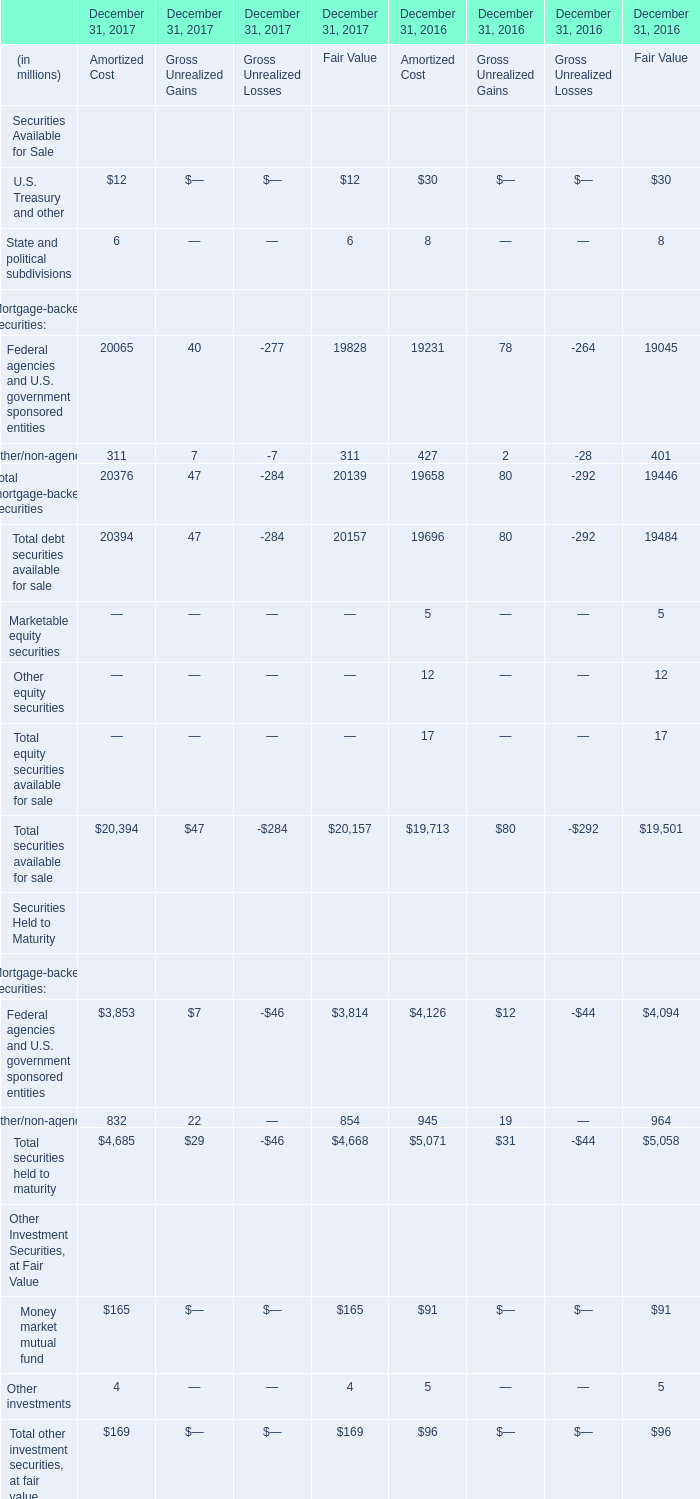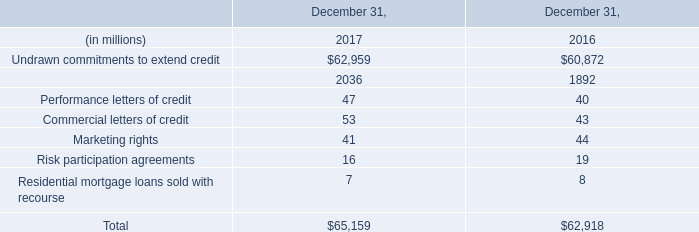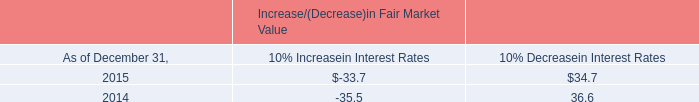What is the sum of Total debt securities available for sale in 2017 for Fair Value? (in million) 
Answer: 20157. 